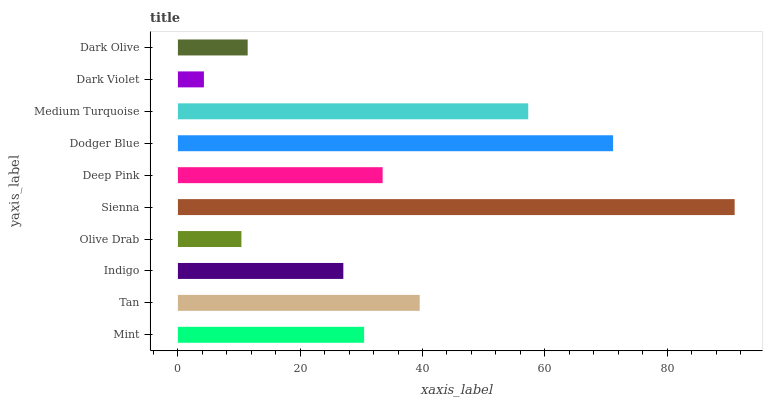Is Dark Violet the minimum?
Answer yes or no. Yes. Is Sienna the maximum?
Answer yes or no. Yes. Is Tan the minimum?
Answer yes or no. No. Is Tan the maximum?
Answer yes or no. No. Is Tan greater than Mint?
Answer yes or no. Yes. Is Mint less than Tan?
Answer yes or no. Yes. Is Mint greater than Tan?
Answer yes or no. No. Is Tan less than Mint?
Answer yes or no. No. Is Deep Pink the high median?
Answer yes or no. Yes. Is Mint the low median?
Answer yes or no. Yes. Is Dodger Blue the high median?
Answer yes or no. No. Is Deep Pink the low median?
Answer yes or no. No. 